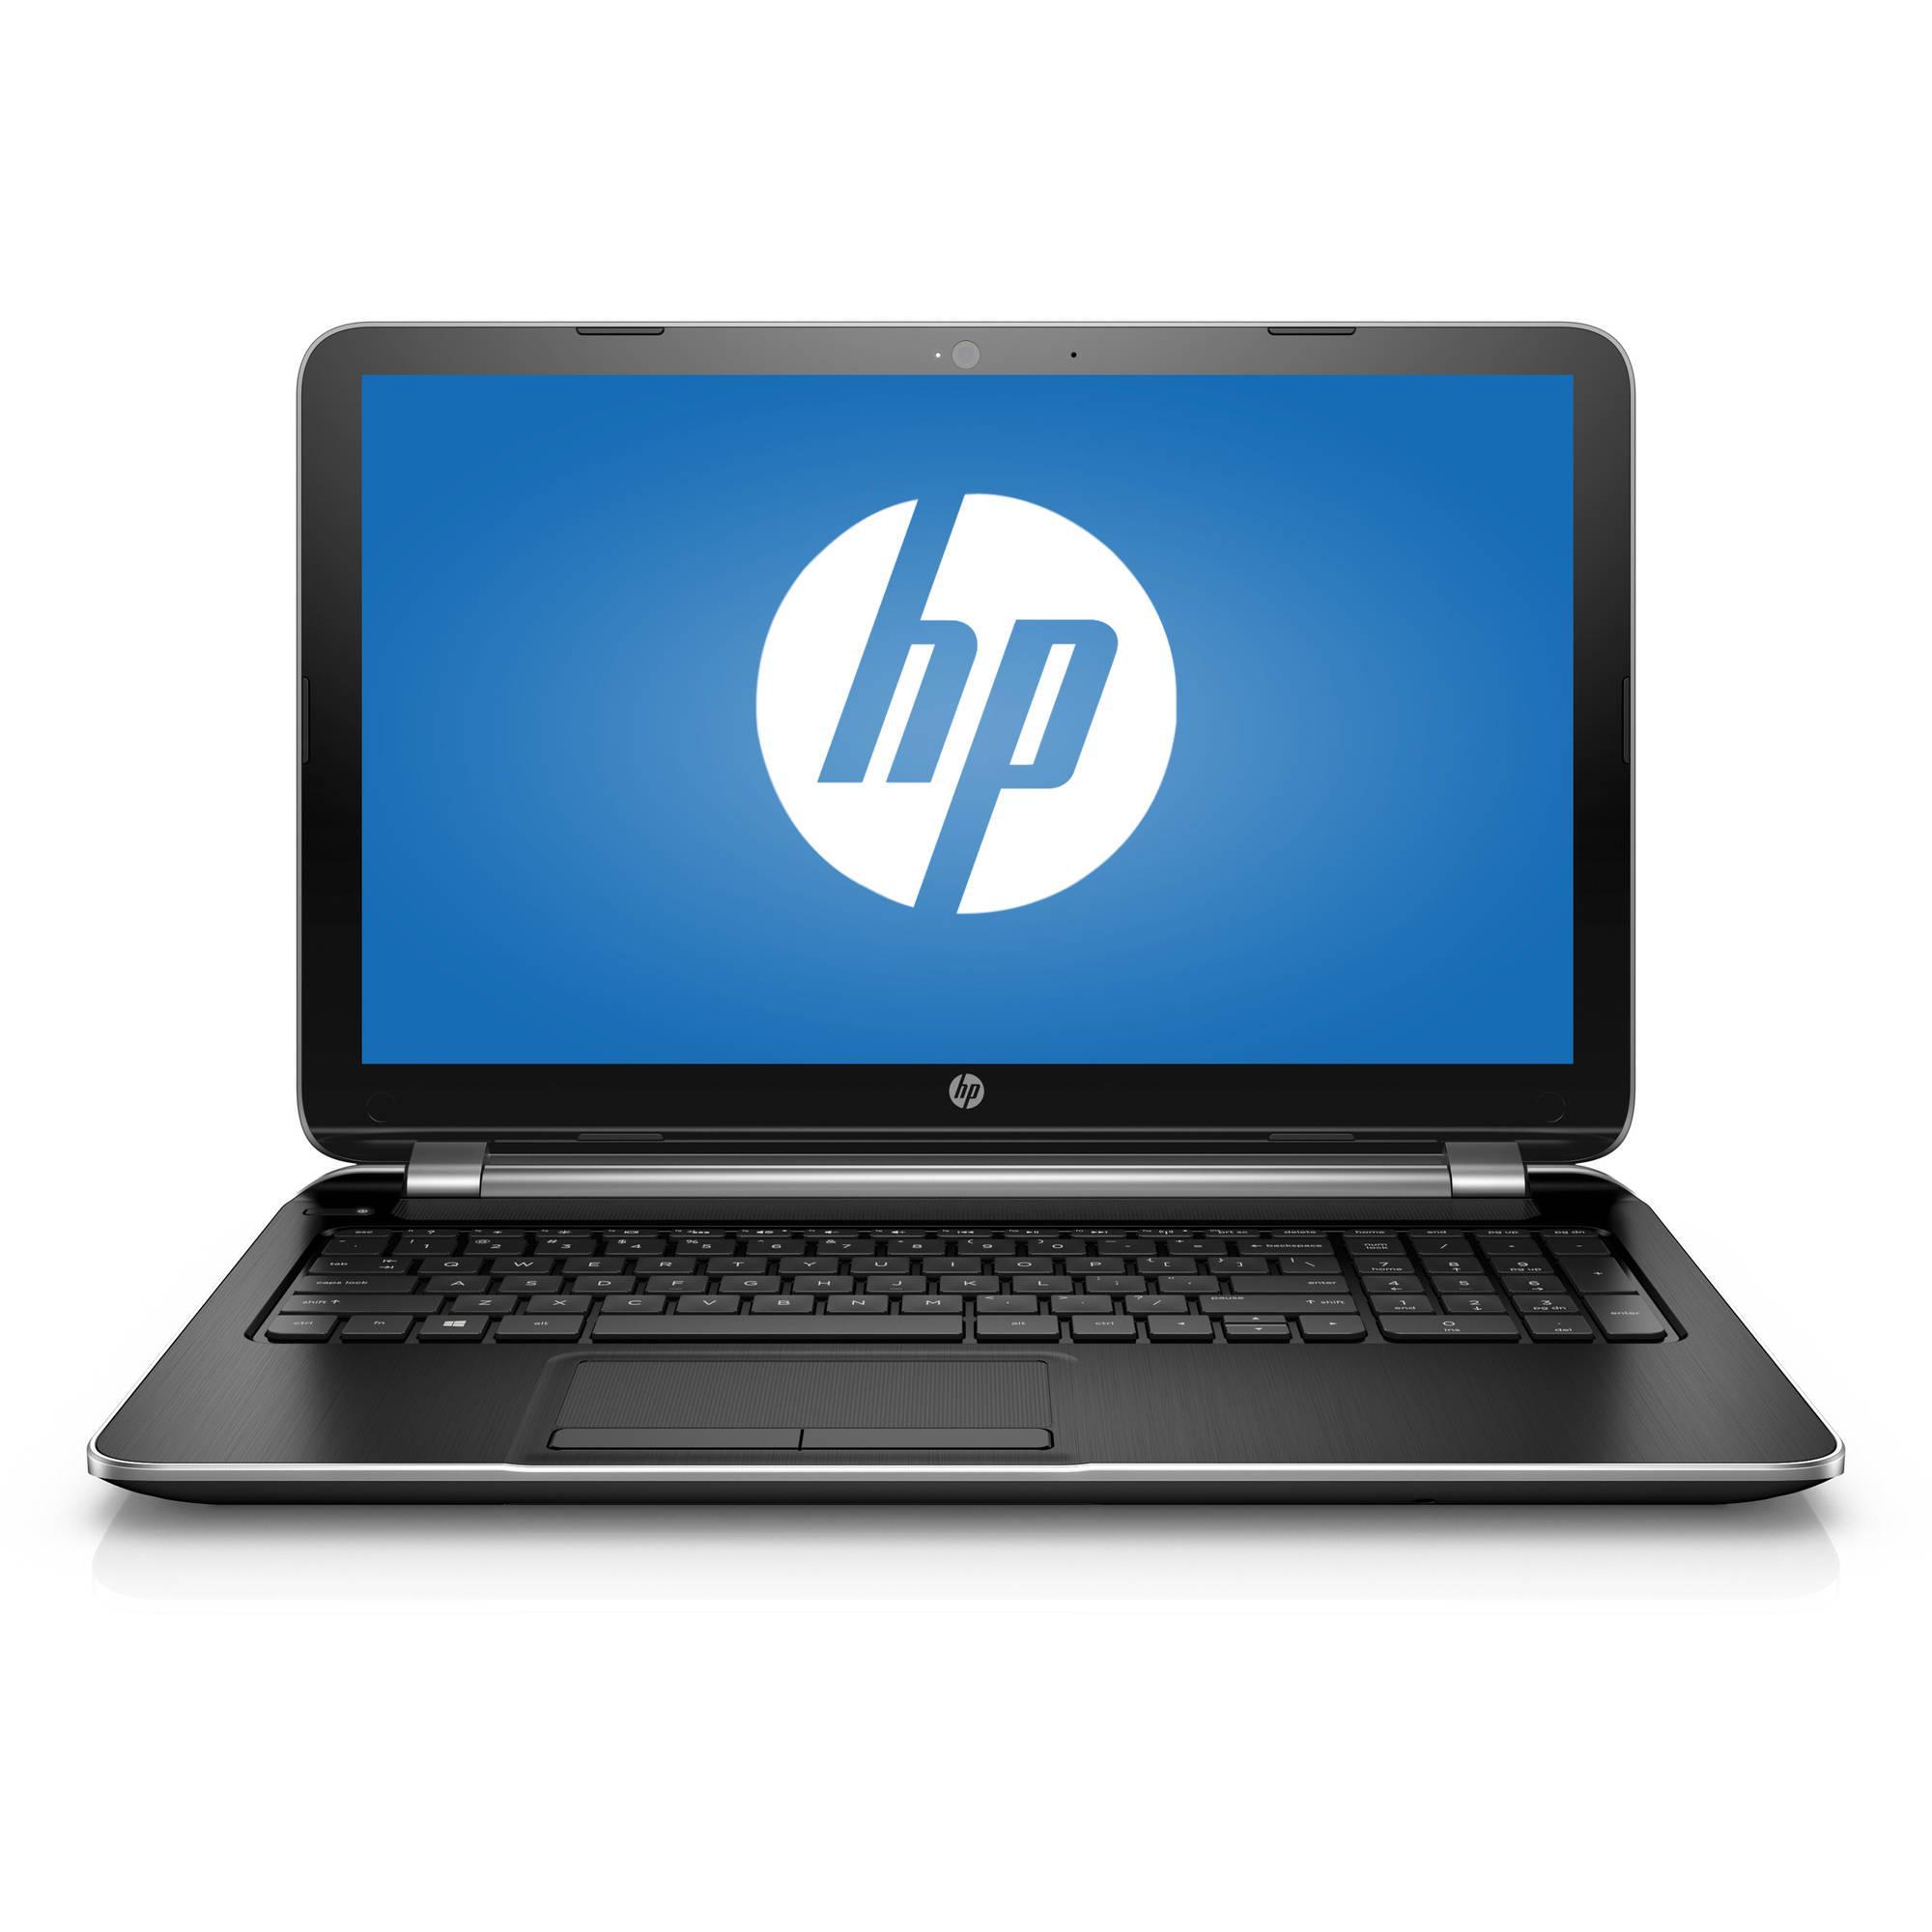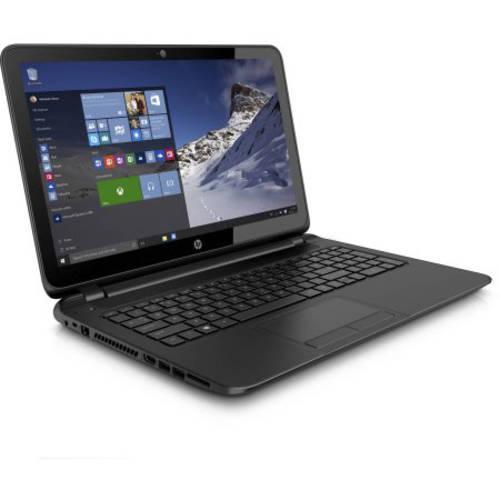The first image is the image on the left, the second image is the image on the right. For the images displayed, is the sentence "Apps are shown on exactly one of the laptops." factually correct? Answer yes or no. Yes. The first image is the image on the left, the second image is the image on the right. Analyze the images presented: Is the assertion "Each image shows one opened laptop displayed turned at an angle." valid? Answer yes or no. No. 